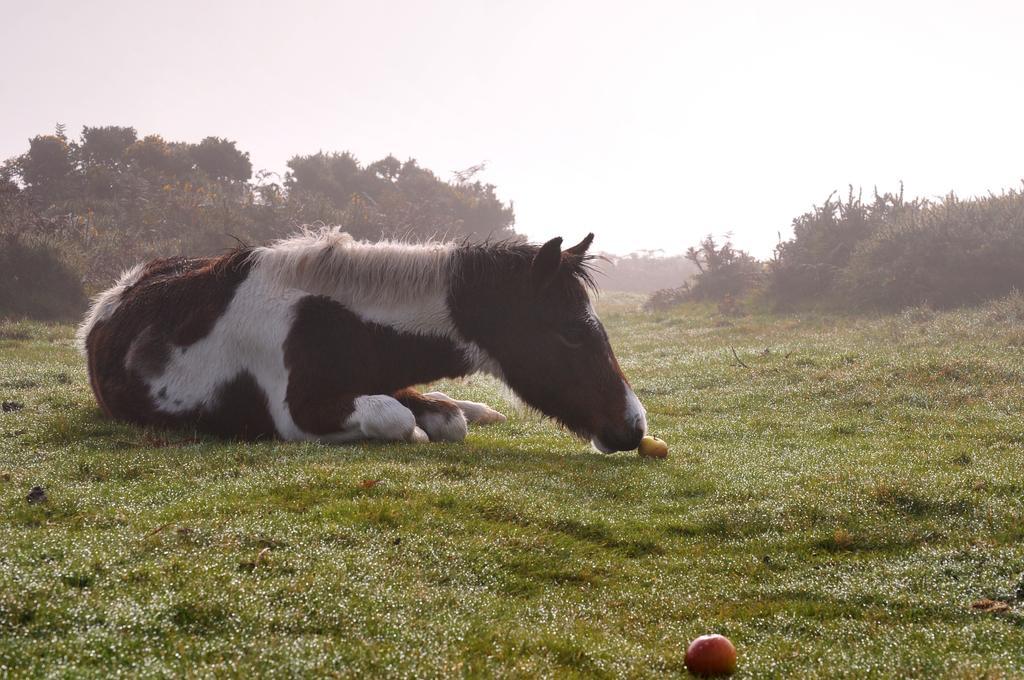In one or two sentences, can you explain what this image depicts? In this picture I can see an animal on the grass, some fruits and around there are some trees. 